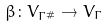Convert formula to latex. <formula><loc_0><loc_0><loc_500><loc_500>\beta \colon V _ { \Gamma ^ { \# } } \to V _ { \Gamma }</formula> 